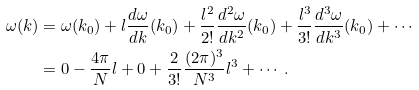Convert formula to latex. <formula><loc_0><loc_0><loc_500><loc_500>\omega ( k ) & = \omega ( k _ { 0 } ) + l \frac { d \omega } { d k } ( k _ { 0 } ) + \frac { l ^ { 2 } } { 2 ! } \frac { d ^ { 2 } \omega } { d k ^ { 2 } } ( k _ { 0 } ) + \frac { l ^ { 3 } } { 3 ! } \frac { d ^ { 3 } \omega } { d k ^ { 3 } } ( k _ { 0 } ) + \cdots \\ & = 0 - \frac { 4 \pi } { N } l + 0 + \frac { 2 } { 3 ! } \frac { ( 2 \pi ) ^ { 3 } } { N ^ { 3 } } l ^ { 3 } + \cdots .</formula> 